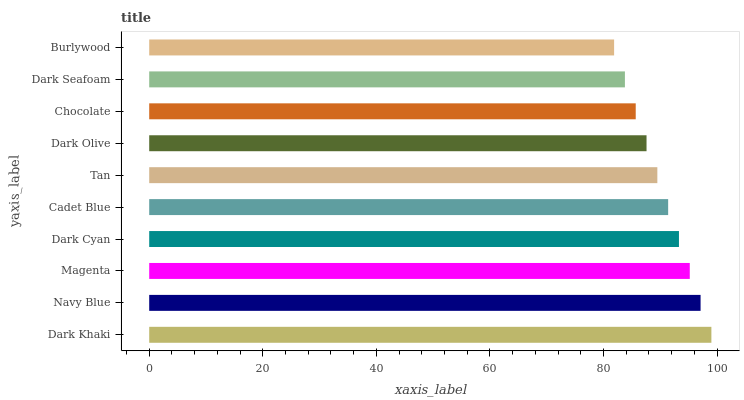Is Burlywood the minimum?
Answer yes or no. Yes. Is Dark Khaki the maximum?
Answer yes or no. Yes. Is Navy Blue the minimum?
Answer yes or no. No. Is Navy Blue the maximum?
Answer yes or no. No. Is Dark Khaki greater than Navy Blue?
Answer yes or no. Yes. Is Navy Blue less than Dark Khaki?
Answer yes or no. Yes. Is Navy Blue greater than Dark Khaki?
Answer yes or no. No. Is Dark Khaki less than Navy Blue?
Answer yes or no. No. Is Cadet Blue the high median?
Answer yes or no. Yes. Is Tan the low median?
Answer yes or no. Yes. Is Burlywood the high median?
Answer yes or no. No. Is Dark Khaki the low median?
Answer yes or no. No. 